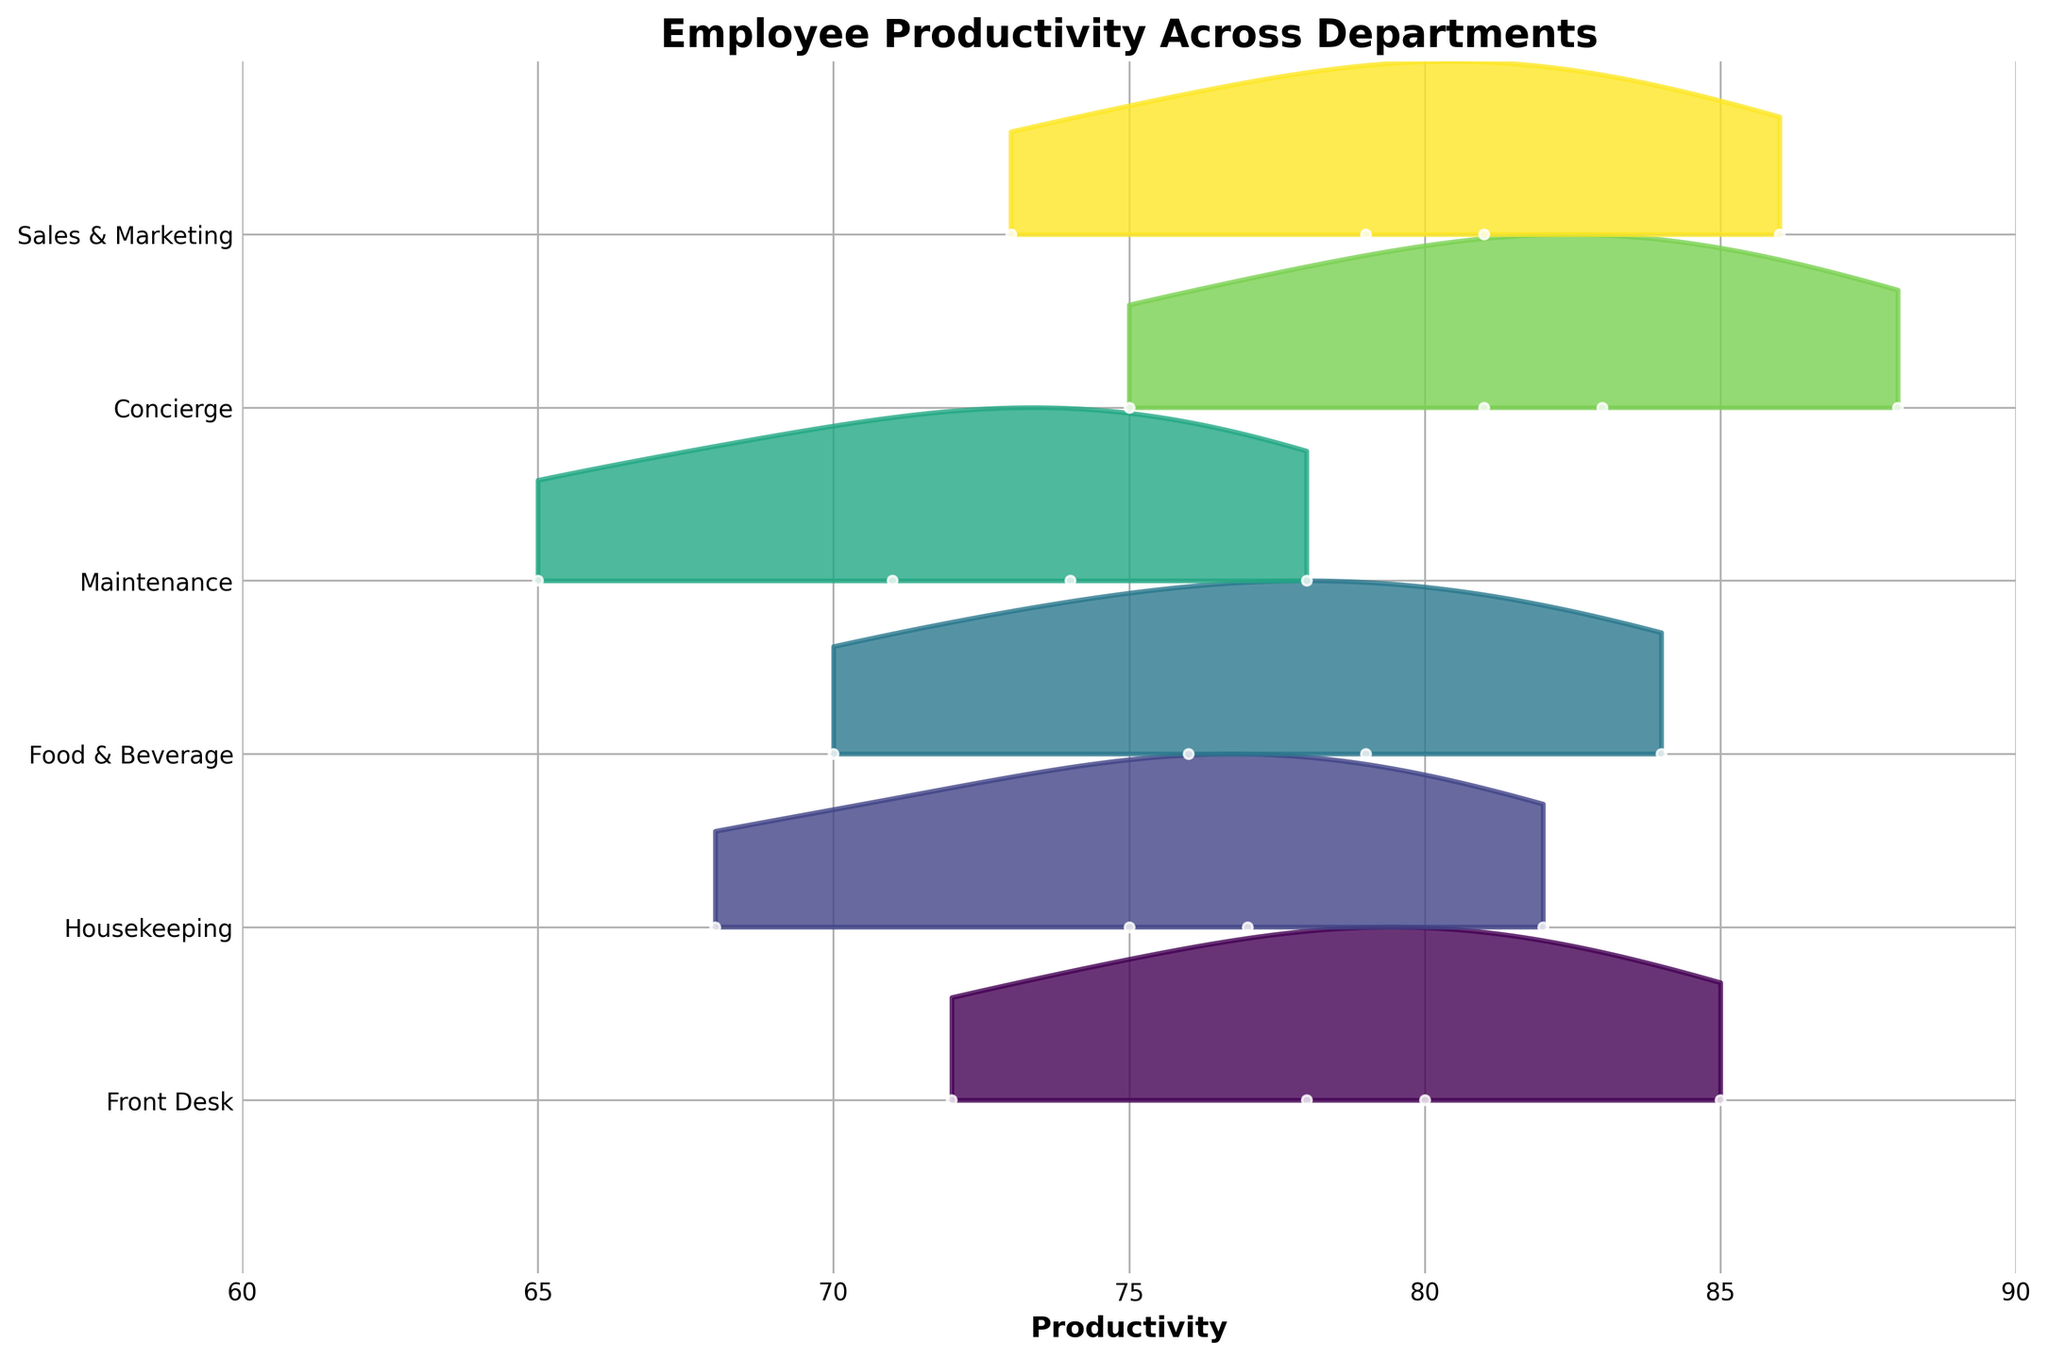How many departments are shown in the plot? The plot has one ridge for each department. Counting these ridges or referring to the y-axis labels will reveal the number of departments.
Answer: 6 Which department shows the highest productivity in Q3? By looking at the peaks of the ridges for Q3, we can see which department has the highest value.
Answer: Concierge What is the range of productivity values for Housekeeping? The ridgeline for Housekeeping stretches from its minimum to maximum productivity values.
Answer: 68 to 82 Between the Front Desk and Sales & Marketing, which department has a higher productivity in Q2? By comparing their productivity points or peaks in Q2, we identify the higher value.
Answer: Sales & Marketing What is the average productivity for Maintenance across all quarters? Summing the productivity values for Maintenance and dividing by the number of quarters will give us the average.
Answer: 72 Identify the department with the greatest increase in productivity from Q1 to Q3. Compute the difference between Q3 and Q1 productivity values for all departments and identify the maximum difference.
Answer: Concierge Are there any departments with overlapping productivity ranges? Look at the ridges to see if any departments' productivity distributions overlap significantly.
Answer: Yes Which department shows the most consistent productivity across all quarters? The department with the narrowest ridge and closest peaks across quarters shows the most consistency.
Answer: Maintenance What is the overall trend in productivity values from Q1 to Q4 for the Food & Beverage department? Observing the ridgeline for Food & Beverage, we can identify if the values generally increase, decrease or stay constant.
Answer: Increase How does the productivity of the Front Desk in Q4 compare to the Housekeeping in Q4? By looking at the specific points or heights for these quarters, we can pinpoint who has higher productivity.
Answer: Front Desk 